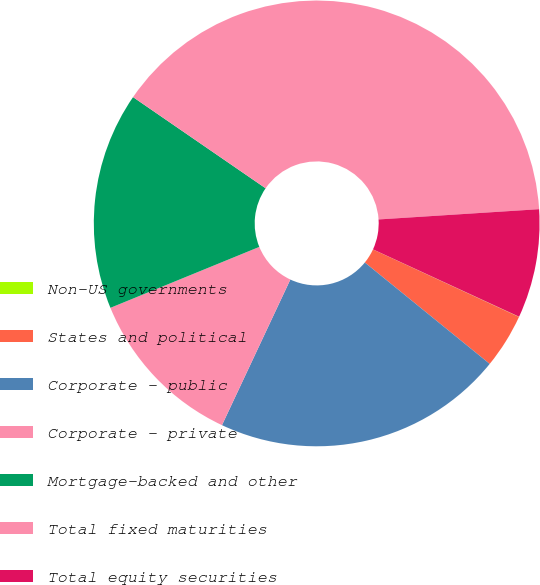<chart> <loc_0><loc_0><loc_500><loc_500><pie_chart><fcel>Non-US governments<fcel>States and political<fcel>Corporate - public<fcel>Corporate - private<fcel>Mortgage-backed and other<fcel>Total fixed maturities<fcel>Total equity securities<nl><fcel>0.02%<fcel>3.96%<fcel>21.13%<fcel>11.83%<fcel>15.77%<fcel>39.39%<fcel>7.89%<nl></chart> 